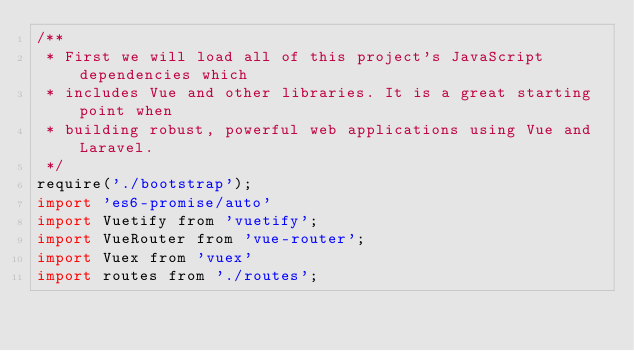<code> <loc_0><loc_0><loc_500><loc_500><_JavaScript_>/**
 * First we will load all of this project's JavaScript dependencies which
 * includes Vue and other libraries. It is a great starting point when
 * building robust, powerful web applications using Vue and Laravel.
 */
require('./bootstrap');
import 'es6-promise/auto'
import Vuetify from 'vuetify';
import VueRouter from 'vue-router';
import Vuex from 'vuex'
import routes from './routes';</code> 